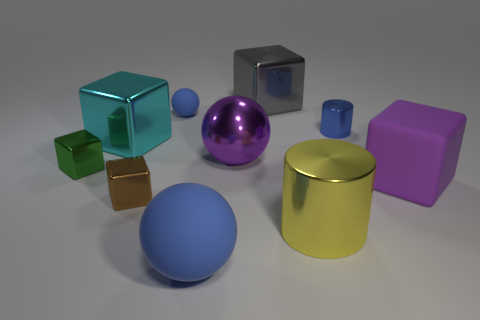There is a matte object to the right of the large metallic sphere; is it the same color as the large metallic cube to the left of the large gray block?
Provide a short and direct response. No. What is the shape of the matte object left of the blue ball that is in front of the rubber cube?
Give a very brief answer. Sphere. Is there another gray metal cube of the same size as the gray metallic block?
Ensure brevity in your answer.  No. How many other large shiny things have the same shape as the cyan thing?
Your answer should be compact. 1. Are there the same number of large cylinders that are behind the yellow metal cylinder and large yellow metallic objects right of the tiny cylinder?
Give a very brief answer. Yes. Is there a tiny green rubber cube?
Make the answer very short. No. There is a cube that is behind the blue sphere that is behind the blue matte object in front of the large cyan cube; what size is it?
Make the answer very short. Large. There is a yellow metal thing that is the same size as the gray cube; what is its shape?
Your answer should be very brief. Cylinder. Is there any other thing that has the same material as the small ball?
Provide a succinct answer. Yes. How many objects are metal things that are in front of the tiny ball or big metal cylinders?
Your response must be concise. 6. 